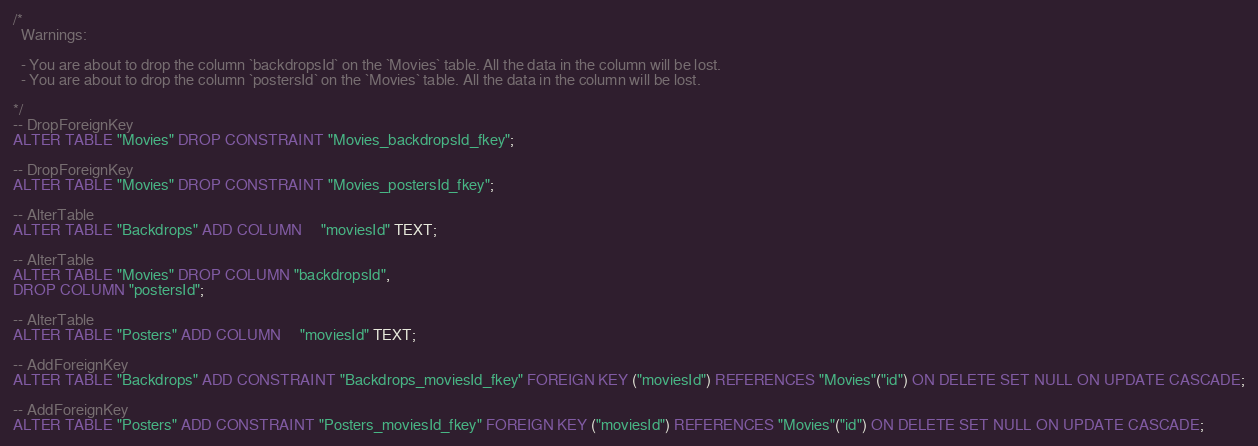Convert code to text. <code><loc_0><loc_0><loc_500><loc_500><_SQL_>/*
  Warnings:

  - You are about to drop the column `backdropsId` on the `Movies` table. All the data in the column will be lost.
  - You are about to drop the column `postersId` on the `Movies` table. All the data in the column will be lost.

*/
-- DropForeignKey
ALTER TABLE "Movies" DROP CONSTRAINT "Movies_backdropsId_fkey";

-- DropForeignKey
ALTER TABLE "Movies" DROP CONSTRAINT "Movies_postersId_fkey";

-- AlterTable
ALTER TABLE "Backdrops" ADD COLUMN     "moviesId" TEXT;

-- AlterTable
ALTER TABLE "Movies" DROP COLUMN "backdropsId",
DROP COLUMN "postersId";

-- AlterTable
ALTER TABLE "Posters" ADD COLUMN     "moviesId" TEXT;

-- AddForeignKey
ALTER TABLE "Backdrops" ADD CONSTRAINT "Backdrops_moviesId_fkey" FOREIGN KEY ("moviesId") REFERENCES "Movies"("id") ON DELETE SET NULL ON UPDATE CASCADE;

-- AddForeignKey
ALTER TABLE "Posters" ADD CONSTRAINT "Posters_moviesId_fkey" FOREIGN KEY ("moviesId") REFERENCES "Movies"("id") ON DELETE SET NULL ON UPDATE CASCADE;
</code> 